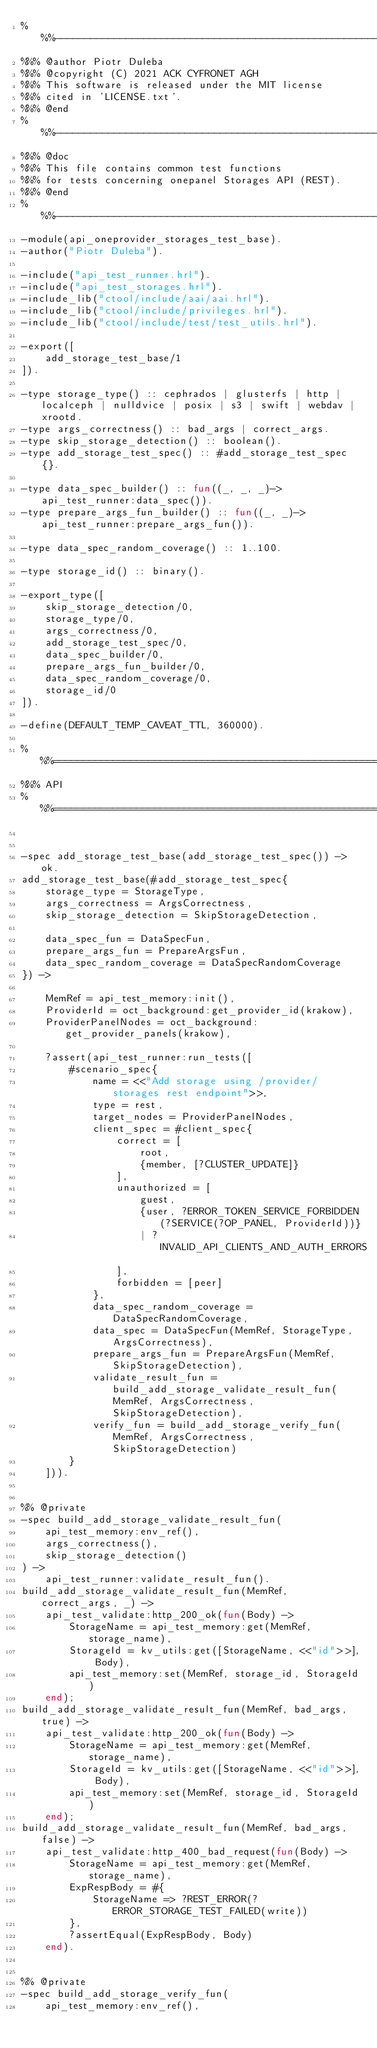<code> <loc_0><loc_0><loc_500><loc_500><_Erlang_>%%%-------------------------------------------------------------------
%%% @author Piotr Duleba
%%% @copyright (C) 2021 ACK CYFRONET AGH
%%% This software is released under the MIT license
%%% cited in 'LICENSE.txt'.
%%% @end
%%%-------------------------------------------------------------------
%%% @doc
%%% This file contains common test functions
%%% for tests concerning onepanel Storages API (REST).
%%% @end
%%%-------------------------------------------------------------------
-module(api_oneprovider_storages_test_base).
-author("Piotr Duleba").

-include("api_test_runner.hrl").
-include("api_test_storages.hrl").
-include_lib("ctool/include/aai/aai.hrl").
-include_lib("ctool/include/privileges.hrl").
-include_lib("ctool/include/test/test_utils.hrl").

-export([
    add_storage_test_base/1
]).

-type storage_type() :: cephrados | glusterfs | http | localceph | nulldvice | posix | s3 | swift | webdav | xrootd.
-type args_correctness() :: bad_args | correct_args.
-type skip_storage_detection() :: boolean().
-type add_storage_test_spec() :: #add_storage_test_spec{}.

-type data_spec_builder() :: fun((_, _, _)-> api_test_runner:data_spec()).
-type prepare_args_fun_builder() :: fun((_, _)-> api_test_runner:prepare_args_fun()).

-type data_spec_random_coverage() :: 1..100.

-type storage_id() :: binary().

-export_type([
    skip_storage_detection/0,
    storage_type/0,
    args_correctness/0,
    add_storage_test_spec/0,
    data_spec_builder/0,
    prepare_args_fun_builder/0,
    data_spec_random_coverage/0,
    storage_id/0
]).

-define(DEFAULT_TEMP_CAVEAT_TTL, 360000).

%%%===================================================================
%%% API
%%%===================================================================


-spec add_storage_test_base(add_storage_test_spec()) -> ok.
add_storage_test_base(#add_storage_test_spec{
    storage_type = StorageType,
    args_correctness = ArgsCorrectness,
    skip_storage_detection = SkipStorageDetection,

    data_spec_fun = DataSpecFun,
    prepare_args_fun = PrepareArgsFun,
    data_spec_random_coverage = DataSpecRandomCoverage
}) ->

    MemRef = api_test_memory:init(),
    ProviderId = oct_background:get_provider_id(krakow),
    ProviderPanelNodes = oct_background:get_provider_panels(krakow),

    ?assert(api_test_runner:run_tests([
        #scenario_spec{
            name = <<"Add storage using /provider/storages rest endpoint">>,
            type = rest,
            target_nodes = ProviderPanelNodes,
            client_spec = #client_spec{
                correct = [
                    root,
                    {member, [?CLUSTER_UPDATE]}
                ],
                unauthorized = [
                    guest,
                    {user, ?ERROR_TOKEN_SERVICE_FORBIDDEN(?SERVICE(?OP_PANEL, ProviderId))}
                    | ?INVALID_API_CLIENTS_AND_AUTH_ERRORS
                ],
                forbidden = [peer]
            },
            data_spec_random_coverage = DataSpecRandomCoverage,
            data_spec = DataSpecFun(MemRef, StorageType, ArgsCorrectness),
            prepare_args_fun = PrepareArgsFun(MemRef, SkipStorageDetection),
            validate_result_fun = build_add_storage_validate_result_fun(MemRef, ArgsCorrectness, SkipStorageDetection),
            verify_fun = build_add_storage_verify_fun(MemRef, ArgsCorrectness, SkipStorageDetection)
        }
    ])).


%% @private
-spec build_add_storage_validate_result_fun(
    api_test_memory:env_ref(),
    args_correctness(),
    skip_storage_detection()
) ->
    api_test_runner:validate_result_fun().
build_add_storage_validate_result_fun(MemRef, correct_args, _) ->
    api_test_validate:http_200_ok(fun(Body) ->
        StorageName = api_test_memory:get(MemRef, storage_name),
        StorageId = kv_utils:get([StorageName, <<"id">>], Body),
        api_test_memory:set(MemRef, storage_id, StorageId)
    end);
build_add_storage_validate_result_fun(MemRef, bad_args, true) ->
    api_test_validate:http_200_ok(fun(Body) ->
        StorageName = api_test_memory:get(MemRef, storage_name),
        StorageId = kv_utils:get([StorageName, <<"id">>], Body),
        api_test_memory:set(MemRef, storage_id, StorageId)
    end);
build_add_storage_validate_result_fun(MemRef, bad_args, false) ->
    api_test_validate:http_400_bad_request(fun(Body) ->
        StorageName = api_test_memory:get(MemRef, storage_name),
        ExpRespBody = #{
            StorageName => ?REST_ERROR(?ERROR_STORAGE_TEST_FAILED(write))
        },
        ?assertEqual(ExpRespBody, Body)
    end).


%% @private
-spec build_add_storage_verify_fun(
    api_test_memory:env_ref(),</code> 